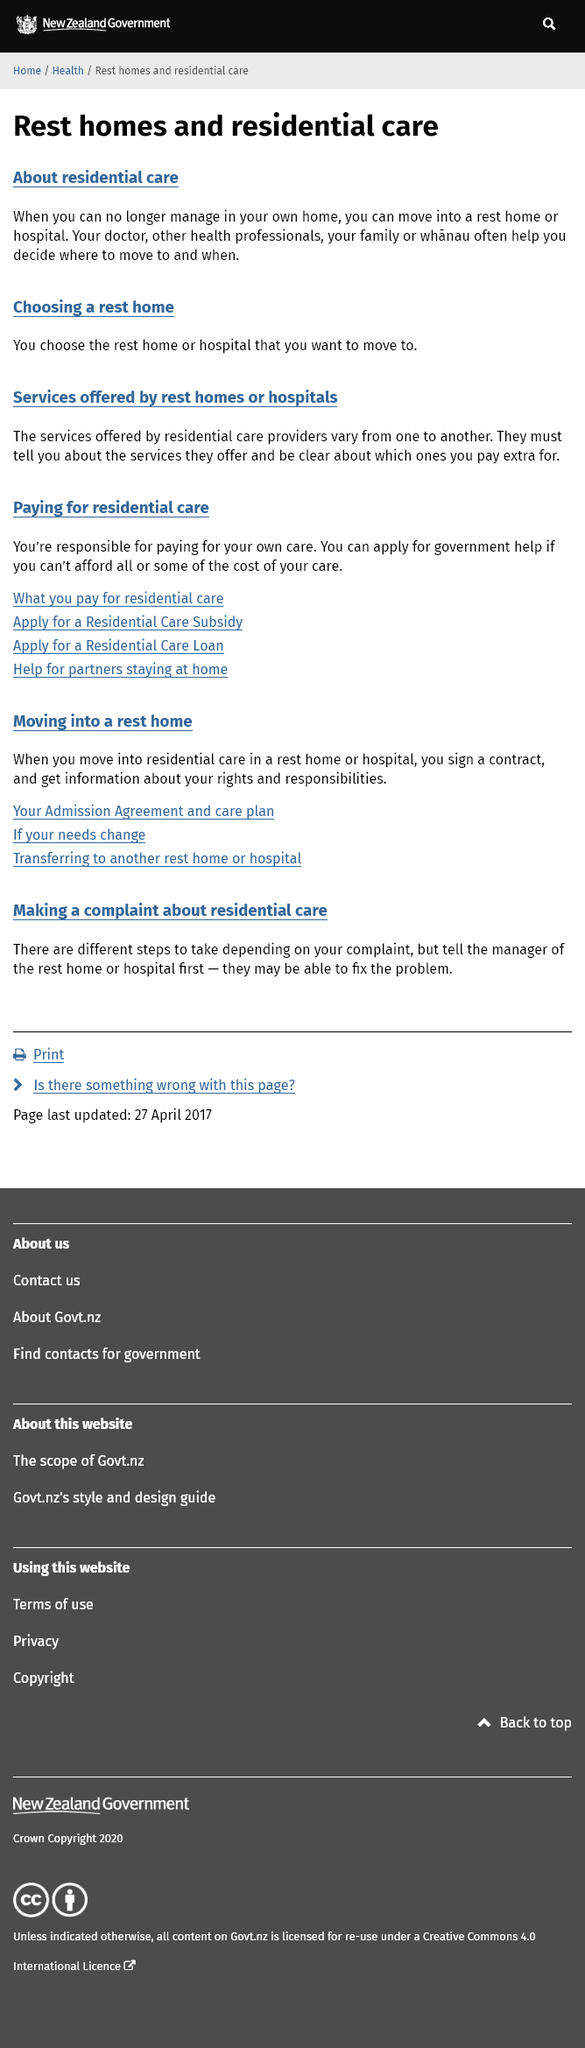Point out several critical features in this image. If you are unable to pay for all or some of the expenses associated with residential care, you may be eligible for government assistance. Yes, the services offered by residential care providers vary from one to another. The decision of where to move and whether or not to be informed of the services offered should be made with the assistance of your doctor, other health professions, your family or whanau, and you should be informed of the services they offer. You are responsible for paying for your own residential care, and no one else is responsible for this payment. It is recommended that you move to a rest home or hospital when you are no longer able to manage independently in your own home. 